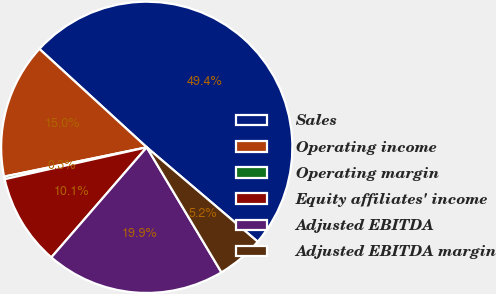<chart> <loc_0><loc_0><loc_500><loc_500><pie_chart><fcel>Sales<fcel>Operating income<fcel>Operating margin<fcel>Equity affiliates' income<fcel>Adjusted EBITDA<fcel>Adjusted EBITDA margin<nl><fcel>49.41%<fcel>15.03%<fcel>0.29%<fcel>10.12%<fcel>19.94%<fcel>5.21%<nl></chart> 